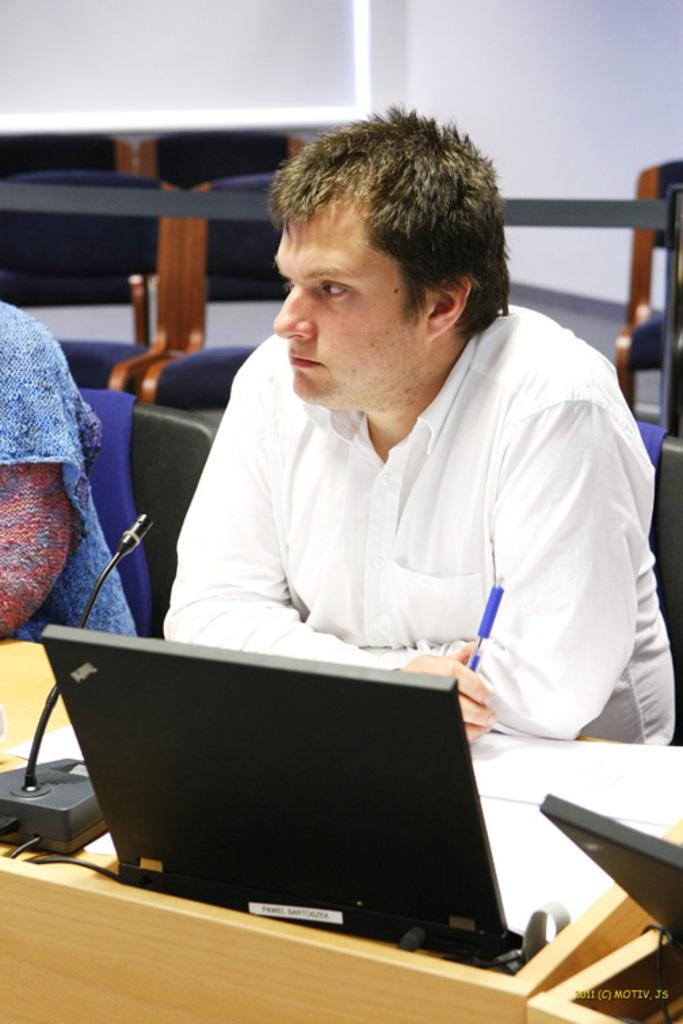What is the man doing in the image? The man is sitting at a desk in the image. What is the man wearing? The man is wearing a white shirt. What is the man holding in his hand? The man is holding a pen. What objects are on the desk with the man? There is a microphone and a laptop on the desk. Reasoning: Let's think step by step by step in order to produce the conversation. We start by identifying the main subject in the image, which is the man sitting at a desk. Then, we expand the conversation to include details about the man's clothing and what he is holding. Finally, we mention the objects on the desk that are relevant to the image. Each question is designed to elicit a specific detail about the image that is known from the provided facts. Absurd Question/Answer: What type of form can be seen being folded in the image? There is no form or folding activity present in the image. What type of harbor can be seen in the image? There is no harbor present in the image. 